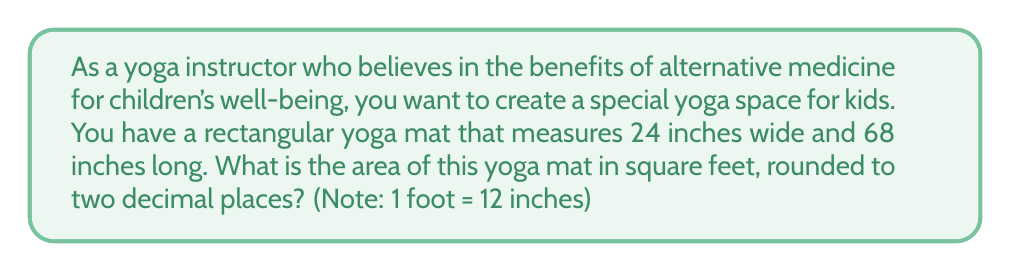Solve this math problem. To solve this problem, we'll follow these steps:

1. Convert the dimensions from inches to feet:
   Width: $24 \text{ inches} = 24 \div 12 = 2 \text{ feet}$
   Length: $68 \text{ inches} = 68 \div 12 = \frac{17}{3} \text{ feet}$

2. Calculate the area using the formula for a rectangle:
   $$A = w \times l$$
   Where $A$ is the area, $w$ is the width, and $l$ is the length.

3. Substitute the values:
   $$A = 2 \times \frac{17}{3}$$

4. Multiply:
   $$A = \frac{34}{3} \text{ square feet}$$

5. Convert the fraction to a decimal and round to two decimal places:
   $$\frac{34}{3} \approx 11.33333...\text{ square feet}$$
   Rounded to two decimal places: $11.33 \text{ square feet}$

[asy]
unitsize(1cm);
draw((0,0)--(6.8,0)--(6.8,2.4)--(0,2.4)--cycle);
label("68 inches", (3.4,0), S);
label("24 inches", (0,1.2), W);
[/asy]
Answer: $11.33 \text{ square feet}$ 